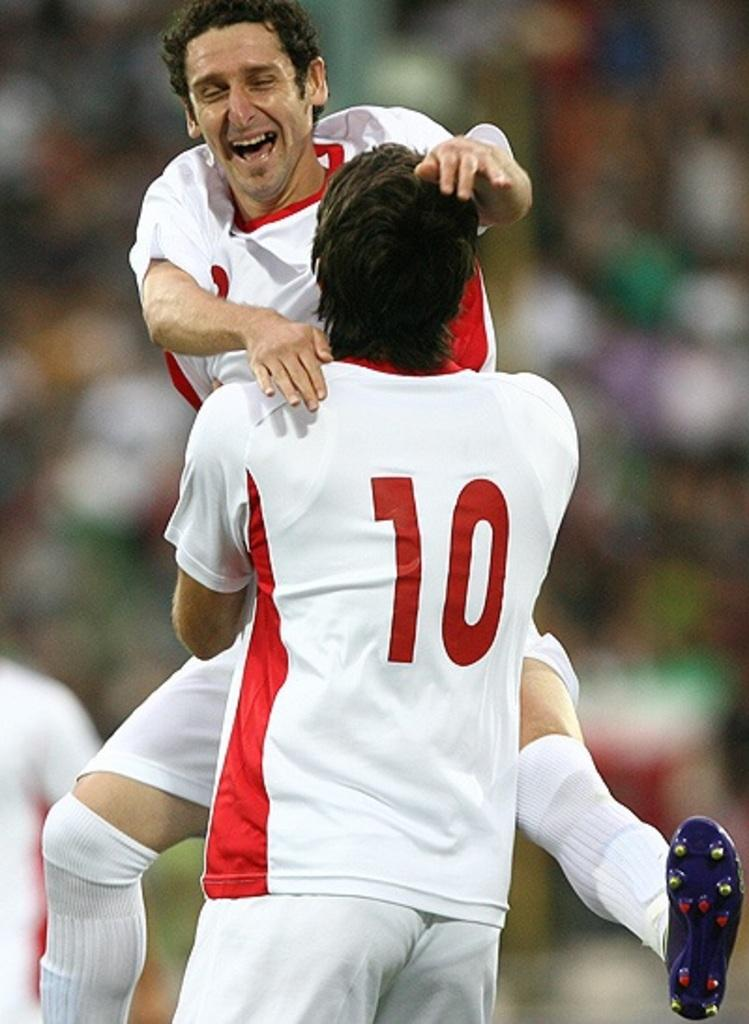How many people are in the image? There are two persons in the image. Can you describe the background of the image? The background of the image is blurred. What type of heat source is visible in the image? There is no heat source visible in the image. How many divisions can be seen in the image? There are no divisions present in the image. 